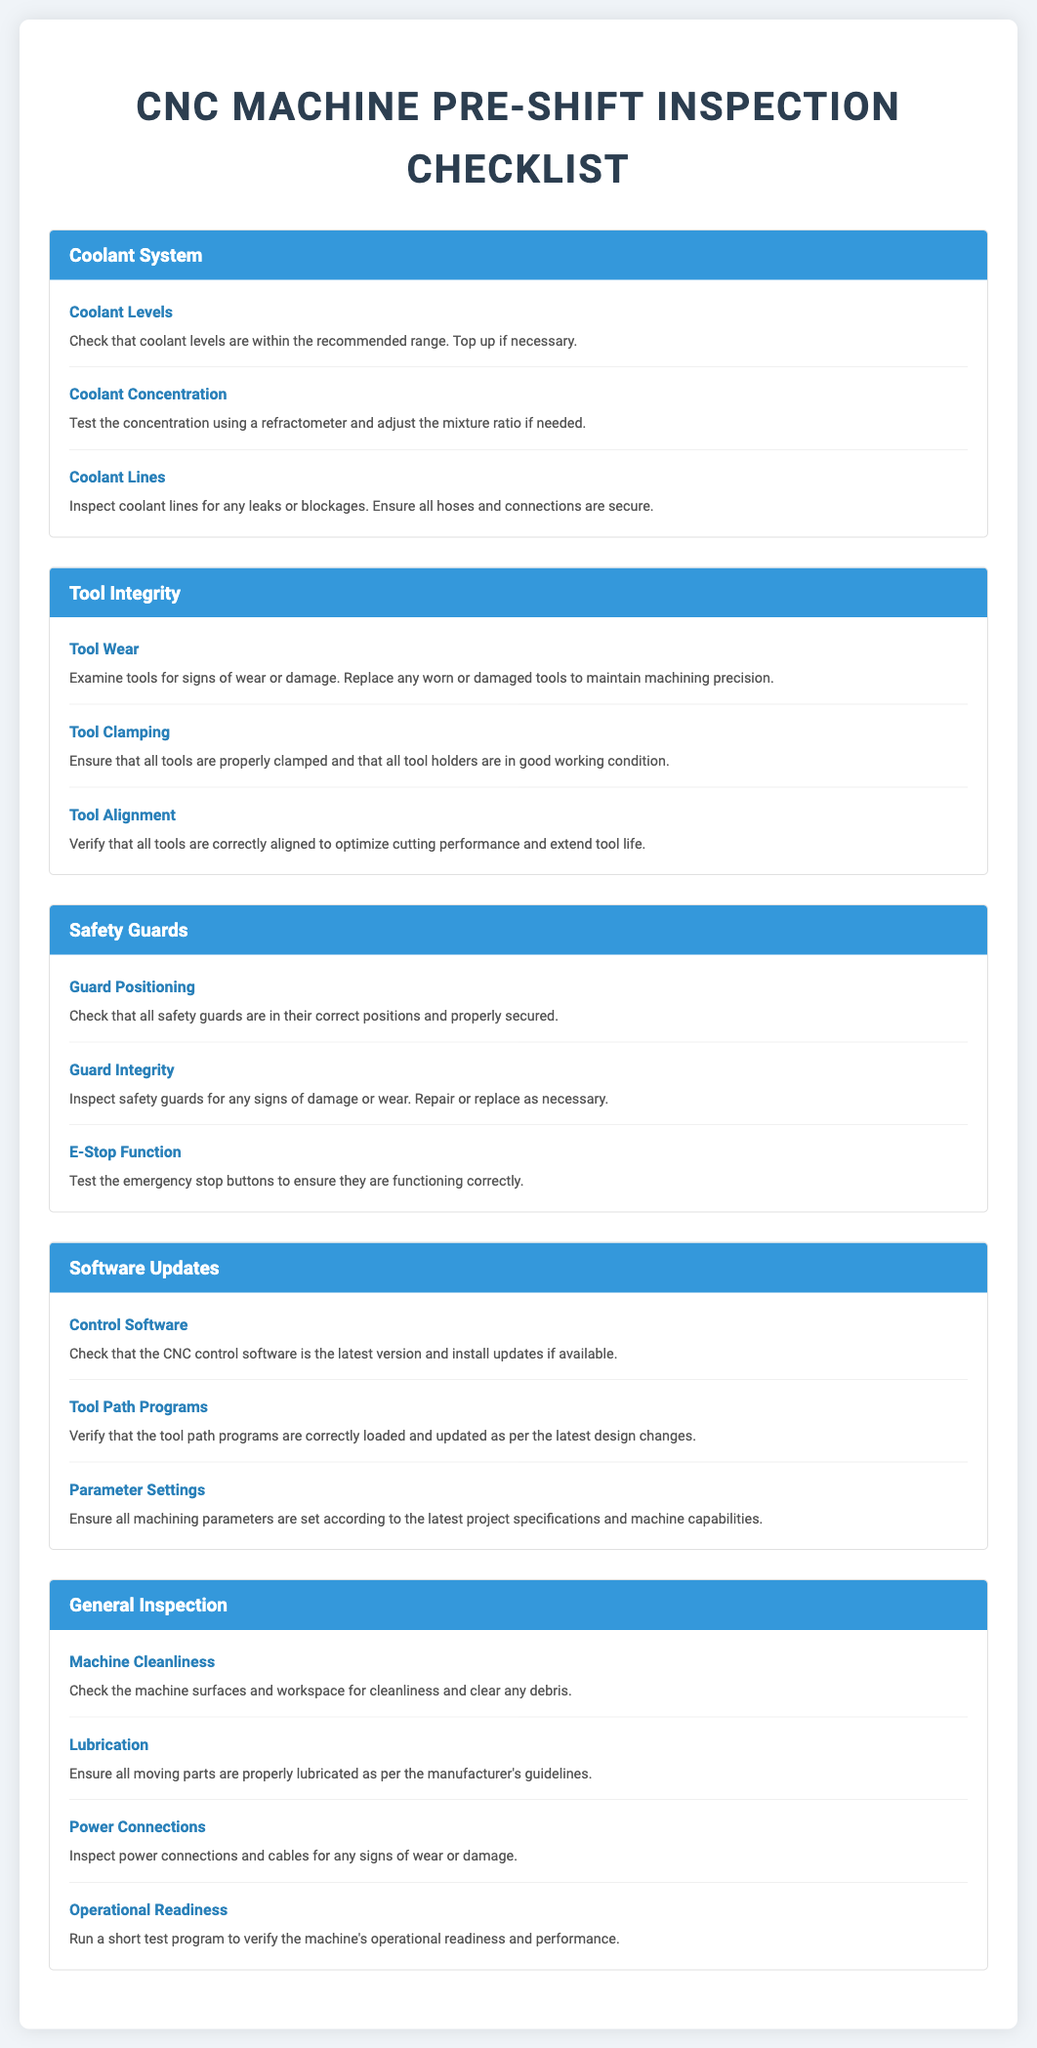what is checked for coolant levels? The checklist indicates that coolant levels must be within the recommended range and topped up if necessary.
Answer: recommended range how should coolant concentration be tested? The document states that coolant concentration should be tested using a refractometer.
Answer: refractometer what needs to be verified for tool alignment? The checklist mentions that it is necessary to verify that all tools are correctly aligned to optimize cutting performance.
Answer: correctly aligned what should be ensured about the emergency stop buttons? The document specifies that the emergency stop buttons must be tested to ensure they are functioning correctly.
Answer: functioning correctly how are machine surfaces checked? The checklist indicates that machine surfaces and workspace must be inspected for cleanliness.
Answer: cleanliness what should be done if a tool is worn or damaged? The document states that any worn or damaged tools should be replaced to maintain machining precision.
Answer: replace how often should software updates be checked? The checklist requires that the CNC control software should be checked to ensure it is the latest version.
Answer: latest version what must be inspected for power connections? The document instructs to inspect power connections and cables for any signs of wear or damage.
Answer: wear or damage how is the operational readiness of the machine verified? According to the checklist, a short test program should be run to verify the machine's operational readiness and performance.
Answer: short test program 